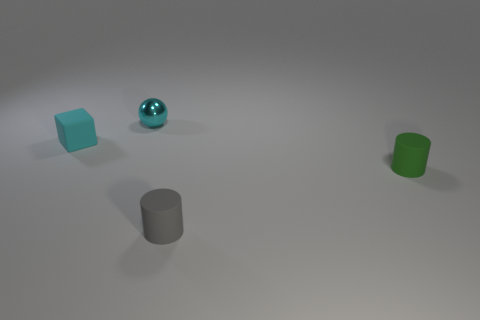Add 3 small green objects. How many objects exist? 7 Subtract all spheres. How many objects are left? 3 Subtract 1 cubes. How many cubes are left? 0 Subtract all big red cubes. Subtract all tiny matte objects. How many objects are left? 1 Add 1 cyan blocks. How many cyan blocks are left? 2 Add 1 rubber cubes. How many rubber cubes exist? 2 Subtract all green cylinders. How many cylinders are left? 1 Subtract 0 red blocks. How many objects are left? 4 Subtract all yellow cubes. Subtract all yellow spheres. How many cubes are left? 1 Subtract all gray spheres. How many green cylinders are left? 1 